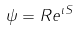<formula> <loc_0><loc_0><loc_500><loc_500>\psi = R e ^ { \imath S }</formula> 